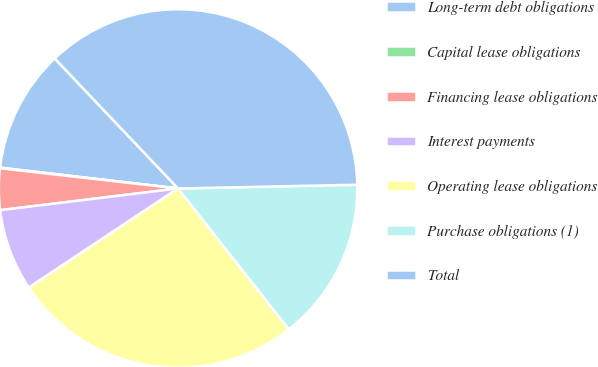<chart> <loc_0><loc_0><loc_500><loc_500><pie_chart><fcel>Long-term debt obligations<fcel>Capital lease obligations<fcel>Financing lease obligations<fcel>Interest payments<fcel>Operating lease obligations<fcel>Purchase obligations (1)<fcel>Total<nl><fcel>11.06%<fcel>0.06%<fcel>3.73%<fcel>7.4%<fcel>26.27%<fcel>14.73%<fcel>36.75%<nl></chart> 